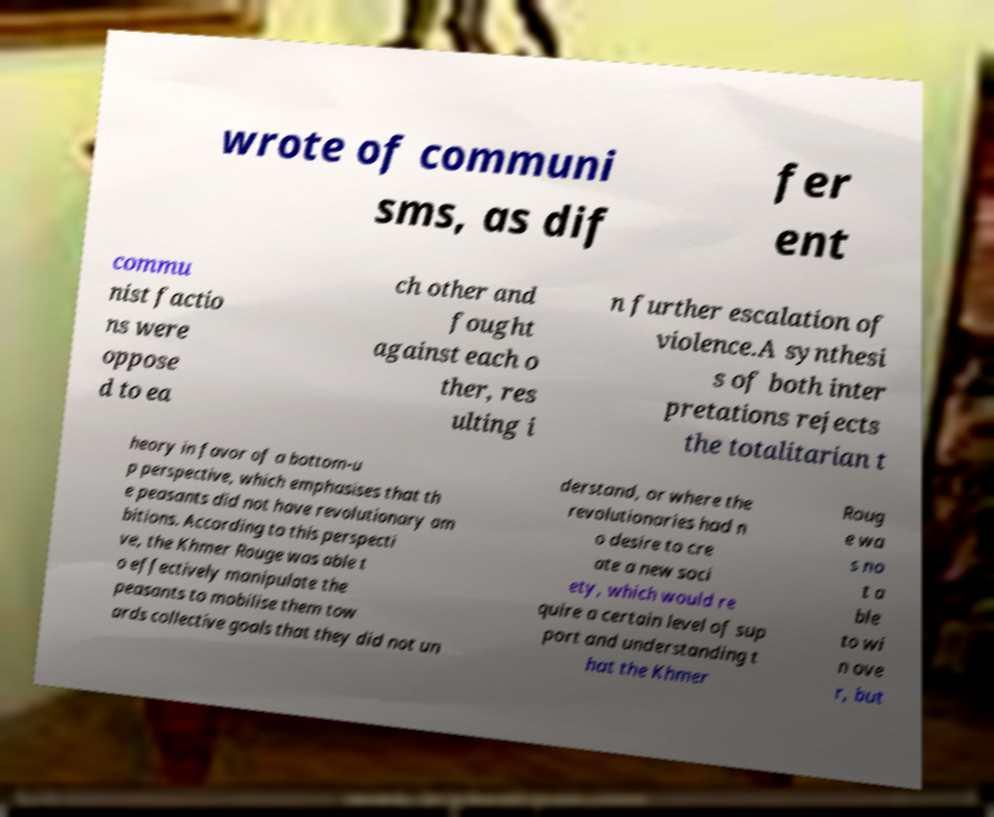I need the written content from this picture converted into text. Can you do that? wrote of communi sms, as dif fer ent commu nist factio ns were oppose d to ea ch other and fought against each o ther, res ulting i n further escalation of violence.A synthesi s of both inter pretations rejects the totalitarian t heory in favor of a bottom-u p perspective, which emphasises that th e peasants did not have revolutionary am bitions. According to this perspecti ve, the Khmer Rouge was able t o effectively manipulate the peasants to mobilise them tow ards collective goals that they did not un derstand, or where the revolutionaries had n o desire to cre ate a new soci ety, which would re quire a certain level of sup port and understanding t hat the Khmer Roug e wa s no t a ble to wi n ove r, but 